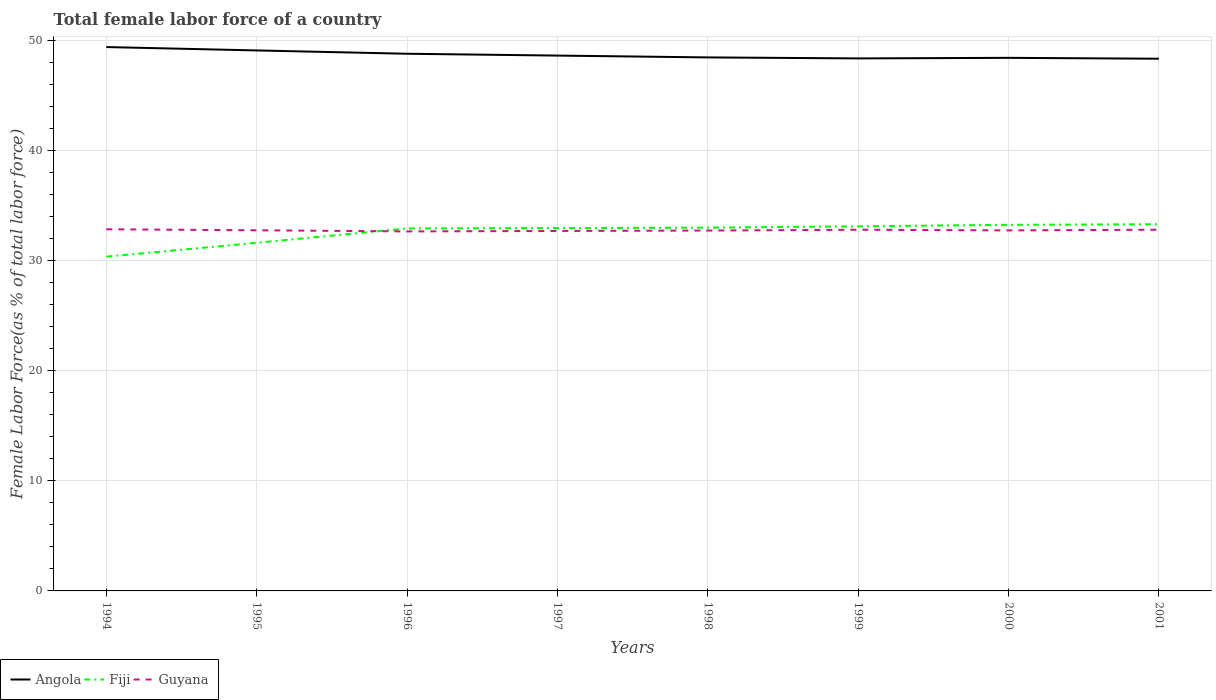How many different coloured lines are there?
Keep it short and to the point. 3. Is the number of lines equal to the number of legend labels?
Offer a terse response. Yes. Across all years, what is the maximum percentage of female labor force in Angola?
Your answer should be very brief. 48.34. What is the total percentage of female labor force in Fiji in the graph?
Give a very brief answer. -0.12. What is the difference between the highest and the second highest percentage of female labor force in Angola?
Ensure brevity in your answer.  1.06. What is the difference between the highest and the lowest percentage of female labor force in Angola?
Your answer should be compact. 3. How many lines are there?
Offer a very short reply. 3. Are the values on the major ticks of Y-axis written in scientific E-notation?
Ensure brevity in your answer.  No. Does the graph contain grids?
Your answer should be compact. Yes. Where does the legend appear in the graph?
Provide a succinct answer. Bottom left. How many legend labels are there?
Your answer should be compact. 3. What is the title of the graph?
Provide a short and direct response. Total female labor force of a country. Does "Guam" appear as one of the legend labels in the graph?
Your answer should be compact. No. What is the label or title of the X-axis?
Provide a succinct answer. Years. What is the label or title of the Y-axis?
Your answer should be very brief. Female Labor Force(as % of total labor force). What is the Female Labor Force(as % of total labor force) in Angola in 1994?
Your answer should be compact. 49.4. What is the Female Labor Force(as % of total labor force) of Fiji in 1994?
Give a very brief answer. 30.36. What is the Female Labor Force(as % of total labor force) in Guyana in 1994?
Offer a very short reply. 32.85. What is the Female Labor Force(as % of total labor force) of Angola in 1995?
Your answer should be compact. 49.09. What is the Female Labor Force(as % of total labor force) in Fiji in 1995?
Keep it short and to the point. 31.62. What is the Female Labor Force(as % of total labor force) in Guyana in 1995?
Your answer should be very brief. 32.76. What is the Female Labor Force(as % of total labor force) of Angola in 1996?
Offer a very short reply. 48.79. What is the Female Labor Force(as % of total labor force) in Fiji in 1996?
Give a very brief answer. 32.92. What is the Female Labor Force(as % of total labor force) in Guyana in 1996?
Your answer should be very brief. 32.66. What is the Female Labor Force(as % of total labor force) in Angola in 1997?
Your response must be concise. 48.63. What is the Female Labor Force(as % of total labor force) in Fiji in 1997?
Give a very brief answer. 32.96. What is the Female Labor Force(as % of total labor force) in Guyana in 1997?
Your response must be concise. 32.69. What is the Female Labor Force(as % of total labor force) in Angola in 1998?
Offer a very short reply. 48.46. What is the Female Labor Force(as % of total labor force) of Fiji in 1998?
Your answer should be very brief. 33. What is the Female Labor Force(as % of total labor force) of Guyana in 1998?
Offer a terse response. 32.73. What is the Female Labor Force(as % of total labor force) in Angola in 1999?
Keep it short and to the point. 48.37. What is the Female Labor Force(as % of total labor force) of Fiji in 1999?
Keep it short and to the point. 33.12. What is the Female Labor Force(as % of total labor force) in Guyana in 1999?
Provide a short and direct response. 32.81. What is the Female Labor Force(as % of total labor force) of Angola in 2000?
Keep it short and to the point. 48.42. What is the Female Labor Force(as % of total labor force) of Fiji in 2000?
Provide a short and direct response. 33.25. What is the Female Labor Force(as % of total labor force) of Guyana in 2000?
Provide a succinct answer. 32.75. What is the Female Labor Force(as % of total labor force) in Angola in 2001?
Provide a succinct answer. 48.34. What is the Female Labor Force(as % of total labor force) in Fiji in 2001?
Your response must be concise. 33.31. What is the Female Labor Force(as % of total labor force) of Guyana in 2001?
Keep it short and to the point. 32.81. Across all years, what is the maximum Female Labor Force(as % of total labor force) of Angola?
Keep it short and to the point. 49.4. Across all years, what is the maximum Female Labor Force(as % of total labor force) in Fiji?
Ensure brevity in your answer.  33.31. Across all years, what is the maximum Female Labor Force(as % of total labor force) in Guyana?
Your response must be concise. 32.85. Across all years, what is the minimum Female Labor Force(as % of total labor force) in Angola?
Your answer should be very brief. 48.34. Across all years, what is the minimum Female Labor Force(as % of total labor force) in Fiji?
Make the answer very short. 30.36. Across all years, what is the minimum Female Labor Force(as % of total labor force) in Guyana?
Provide a short and direct response. 32.66. What is the total Female Labor Force(as % of total labor force) of Angola in the graph?
Give a very brief answer. 389.51. What is the total Female Labor Force(as % of total labor force) of Fiji in the graph?
Your answer should be very brief. 260.55. What is the total Female Labor Force(as % of total labor force) in Guyana in the graph?
Keep it short and to the point. 262.06. What is the difference between the Female Labor Force(as % of total labor force) in Angola in 1994 and that in 1995?
Ensure brevity in your answer.  0.31. What is the difference between the Female Labor Force(as % of total labor force) of Fiji in 1994 and that in 1995?
Offer a very short reply. -1.26. What is the difference between the Female Labor Force(as % of total labor force) in Guyana in 1994 and that in 1995?
Keep it short and to the point. 0.09. What is the difference between the Female Labor Force(as % of total labor force) of Angola in 1994 and that in 1996?
Offer a very short reply. 0.61. What is the difference between the Female Labor Force(as % of total labor force) of Fiji in 1994 and that in 1996?
Offer a terse response. -2.56. What is the difference between the Female Labor Force(as % of total labor force) in Guyana in 1994 and that in 1996?
Offer a terse response. 0.19. What is the difference between the Female Labor Force(as % of total labor force) of Angola in 1994 and that in 1997?
Give a very brief answer. 0.77. What is the difference between the Female Labor Force(as % of total labor force) of Fiji in 1994 and that in 1997?
Keep it short and to the point. -2.6. What is the difference between the Female Labor Force(as % of total labor force) in Guyana in 1994 and that in 1997?
Give a very brief answer. 0.15. What is the difference between the Female Labor Force(as % of total labor force) of Angola in 1994 and that in 1998?
Provide a succinct answer. 0.94. What is the difference between the Female Labor Force(as % of total labor force) in Fiji in 1994 and that in 1998?
Ensure brevity in your answer.  -2.64. What is the difference between the Female Labor Force(as % of total labor force) in Guyana in 1994 and that in 1998?
Make the answer very short. 0.12. What is the difference between the Female Labor Force(as % of total labor force) in Angola in 1994 and that in 1999?
Give a very brief answer. 1.03. What is the difference between the Female Labor Force(as % of total labor force) in Fiji in 1994 and that in 1999?
Provide a succinct answer. -2.75. What is the difference between the Female Labor Force(as % of total labor force) in Guyana in 1994 and that in 1999?
Provide a succinct answer. 0.04. What is the difference between the Female Labor Force(as % of total labor force) of Angola in 1994 and that in 2000?
Offer a terse response. 0.98. What is the difference between the Female Labor Force(as % of total labor force) of Fiji in 1994 and that in 2000?
Your response must be concise. -2.89. What is the difference between the Female Labor Force(as % of total labor force) of Guyana in 1994 and that in 2000?
Offer a terse response. 0.1. What is the difference between the Female Labor Force(as % of total labor force) of Angola in 1994 and that in 2001?
Offer a terse response. 1.06. What is the difference between the Female Labor Force(as % of total labor force) in Fiji in 1994 and that in 2001?
Your response must be concise. -2.94. What is the difference between the Female Labor Force(as % of total labor force) in Guyana in 1994 and that in 2001?
Offer a terse response. 0.04. What is the difference between the Female Labor Force(as % of total labor force) of Angola in 1995 and that in 1996?
Keep it short and to the point. 0.3. What is the difference between the Female Labor Force(as % of total labor force) of Fiji in 1995 and that in 1996?
Provide a short and direct response. -1.3. What is the difference between the Female Labor Force(as % of total labor force) in Guyana in 1995 and that in 1996?
Provide a succinct answer. 0.1. What is the difference between the Female Labor Force(as % of total labor force) in Angola in 1995 and that in 1997?
Offer a terse response. 0.47. What is the difference between the Female Labor Force(as % of total labor force) in Fiji in 1995 and that in 1997?
Provide a short and direct response. -1.34. What is the difference between the Female Labor Force(as % of total labor force) of Guyana in 1995 and that in 1997?
Keep it short and to the point. 0.06. What is the difference between the Female Labor Force(as % of total labor force) in Angola in 1995 and that in 1998?
Provide a short and direct response. 0.63. What is the difference between the Female Labor Force(as % of total labor force) in Fiji in 1995 and that in 1998?
Keep it short and to the point. -1.38. What is the difference between the Female Labor Force(as % of total labor force) in Guyana in 1995 and that in 1998?
Ensure brevity in your answer.  0.03. What is the difference between the Female Labor Force(as % of total labor force) of Angola in 1995 and that in 1999?
Give a very brief answer. 0.72. What is the difference between the Female Labor Force(as % of total labor force) of Fiji in 1995 and that in 1999?
Make the answer very short. -1.49. What is the difference between the Female Labor Force(as % of total labor force) in Guyana in 1995 and that in 1999?
Your response must be concise. -0.05. What is the difference between the Female Labor Force(as % of total labor force) in Angola in 1995 and that in 2000?
Make the answer very short. 0.67. What is the difference between the Female Labor Force(as % of total labor force) in Fiji in 1995 and that in 2000?
Make the answer very short. -1.63. What is the difference between the Female Labor Force(as % of total labor force) of Guyana in 1995 and that in 2000?
Your answer should be very brief. 0.01. What is the difference between the Female Labor Force(as % of total labor force) in Angola in 1995 and that in 2001?
Offer a terse response. 0.75. What is the difference between the Female Labor Force(as % of total labor force) in Fiji in 1995 and that in 2001?
Keep it short and to the point. -1.68. What is the difference between the Female Labor Force(as % of total labor force) of Guyana in 1995 and that in 2001?
Your response must be concise. -0.05. What is the difference between the Female Labor Force(as % of total labor force) in Angola in 1996 and that in 1997?
Provide a short and direct response. 0.17. What is the difference between the Female Labor Force(as % of total labor force) in Fiji in 1996 and that in 1997?
Your response must be concise. -0.04. What is the difference between the Female Labor Force(as % of total labor force) in Guyana in 1996 and that in 1997?
Your answer should be compact. -0.04. What is the difference between the Female Labor Force(as % of total labor force) in Angola in 1996 and that in 1998?
Offer a terse response. 0.33. What is the difference between the Female Labor Force(as % of total labor force) of Fiji in 1996 and that in 1998?
Your response must be concise. -0.08. What is the difference between the Female Labor Force(as % of total labor force) of Guyana in 1996 and that in 1998?
Your answer should be very brief. -0.08. What is the difference between the Female Labor Force(as % of total labor force) in Angola in 1996 and that in 1999?
Offer a terse response. 0.42. What is the difference between the Female Labor Force(as % of total labor force) in Fiji in 1996 and that in 1999?
Your answer should be very brief. -0.19. What is the difference between the Female Labor Force(as % of total labor force) of Guyana in 1996 and that in 1999?
Provide a short and direct response. -0.15. What is the difference between the Female Labor Force(as % of total labor force) in Angola in 1996 and that in 2000?
Offer a terse response. 0.37. What is the difference between the Female Labor Force(as % of total labor force) of Fiji in 1996 and that in 2000?
Your response must be concise. -0.33. What is the difference between the Female Labor Force(as % of total labor force) of Guyana in 1996 and that in 2000?
Keep it short and to the point. -0.09. What is the difference between the Female Labor Force(as % of total labor force) in Angola in 1996 and that in 2001?
Give a very brief answer. 0.45. What is the difference between the Female Labor Force(as % of total labor force) in Fiji in 1996 and that in 2001?
Offer a terse response. -0.38. What is the difference between the Female Labor Force(as % of total labor force) of Guyana in 1996 and that in 2001?
Give a very brief answer. -0.15. What is the difference between the Female Labor Force(as % of total labor force) in Angola in 1997 and that in 1998?
Your answer should be very brief. 0.17. What is the difference between the Female Labor Force(as % of total labor force) in Fiji in 1997 and that in 1998?
Ensure brevity in your answer.  -0.04. What is the difference between the Female Labor Force(as % of total labor force) in Guyana in 1997 and that in 1998?
Your response must be concise. -0.04. What is the difference between the Female Labor Force(as % of total labor force) in Angola in 1997 and that in 1999?
Ensure brevity in your answer.  0.26. What is the difference between the Female Labor Force(as % of total labor force) of Fiji in 1997 and that in 1999?
Give a very brief answer. -0.15. What is the difference between the Female Labor Force(as % of total labor force) of Guyana in 1997 and that in 1999?
Offer a very short reply. -0.11. What is the difference between the Female Labor Force(as % of total labor force) in Angola in 1997 and that in 2000?
Keep it short and to the point. 0.21. What is the difference between the Female Labor Force(as % of total labor force) of Fiji in 1997 and that in 2000?
Make the answer very short. -0.29. What is the difference between the Female Labor Force(as % of total labor force) of Guyana in 1997 and that in 2000?
Make the answer very short. -0.05. What is the difference between the Female Labor Force(as % of total labor force) of Angola in 1997 and that in 2001?
Your response must be concise. 0.29. What is the difference between the Female Labor Force(as % of total labor force) of Fiji in 1997 and that in 2001?
Your answer should be very brief. -0.34. What is the difference between the Female Labor Force(as % of total labor force) of Guyana in 1997 and that in 2001?
Keep it short and to the point. -0.11. What is the difference between the Female Labor Force(as % of total labor force) of Angola in 1998 and that in 1999?
Keep it short and to the point. 0.09. What is the difference between the Female Labor Force(as % of total labor force) of Fiji in 1998 and that in 1999?
Your answer should be compact. -0.12. What is the difference between the Female Labor Force(as % of total labor force) of Guyana in 1998 and that in 1999?
Provide a succinct answer. -0.07. What is the difference between the Female Labor Force(as % of total labor force) of Angola in 1998 and that in 2000?
Ensure brevity in your answer.  0.04. What is the difference between the Female Labor Force(as % of total labor force) of Fiji in 1998 and that in 2000?
Ensure brevity in your answer.  -0.25. What is the difference between the Female Labor Force(as % of total labor force) in Guyana in 1998 and that in 2000?
Make the answer very short. -0.01. What is the difference between the Female Labor Force(as % of total labor force) of Angola in 1998 and that in 2001?
Offer a terse response. 0.12. What is the difference between the Female Labor Force(as % of total labor force) in Fiji in 1998 and that in 2001?
Ensure brevity in your answer.  -0.31. What is the difference between the Female Labor Force(as % of total labor force) in Guyana in 1998 and that in 2001?
Offer a terse response. -0.08. What is the difference between the Female Labor Force(as % of total labor force) in Angola in 1999 and that in 2000?
Provide a succinct answer. -0.05. What is the difference between the Female Labor Force(as % of total labor force) of Fiji in 1999 and that in 2000?
Give a very brief answer. -0.14. What is the difference between the Female Labor Force(as % of total labor force) of Guyana in 1999 and that in 2000?
Ensure brevity in your answer.  0.06. What is the difference between the Female Labor Force(as % of total labor force) of Angola in 1999 and that in 2001?
Your answer should be very brief. 0.03. What is the difference between the Female Labor Force(as % of total labor force) of Fiji in 1999 and that in 2001?
Your answer should be very brief. -0.19. What is the difference between the Female Labor Force(as % of total labor force) of Guyana in 1999 and that in 2001?
Your response must be concise. -0. What is the difference between the Female Labor Force(as % of total labor force) in Angola in 2000 and that in 2001?
Keep it short and to the point. 0.08. What is the difference between the Female Labor Force(as % of total labor force) of Fiji in 2000 and that in 2001?
Provide a short and direct response. -0.05. What is the difference between the Female Labor Force(as % of total labor force) in Guyana in 2000 and that in 2001?
Offer a terse response. -0.06. What is the difference between the Female Labor Force(as % of total labor force) of Angola in 1994 and the Female Labor Force(as % of total labor force) of Fiji in 1995?
Provide a short and direct response. 17.78. What is the difference between the Female Labor Force(as % of total labor force) in Angola in 1994 and the Female Labor Force(as % of total labor force) in Guyana in 1995?
Your answer should be very brief. 16.64. What is the difference between the Female Labor Force(as % of total labor force) of Fiji in 1994 and the Female Labor Force(as % of total labor force) of Guyana in 1995?
Offer a very short reply. -2.4. What is the difference between the Female Labor Force(as % of total labor force) of Angola in 1994 and the Female Labor Force(as % of total labor force) of Fiji in 1996?
Keep it short and to the point. 16.48. What is the difference between the Female Labor Force(as % of total labor force) of Angola in 1994 and the Female Labor Force(as % of total labor force) of Guyana in 1996?
Keep it short and to the point. 16.75. What is the difference between the Female Labor Force(as % of total labor force) of Fiji in 1994 and the Female Labor Force(as % of total labor force) of Guyana in 1996?
Keep it short and to the point. -2.29. What is the difference between the Female Labor Force(as % of total labor force) in Angola in 1994 and the Female Labor Force(as % of total labor force) in Fiji in 1997?
Give a very brief answer. 16.44. What is the difference between the Female Labor Force(as % of total labor force) of Angola in 1994 and the Female Labor Force(as % of total labor force) of Guyana in 1997?
Your answer should be very brief. 16.71. What is the difference between the Female Labor Force(as % of total labor force) in Fiji in 1994 and the Female Labor Force(as % of total labor force) in Guyana in 1997?
Provide a succinct answer. -2.33. What is the difference between the Female Labor Force(as % of total labor force) in Angola in 1994 and the Female Labor Force(as % of total labor force) in Fiji in 1998?
Offer a terse response. 16.4. What is the difference between the Female Labor Force(as % of total labor force) in Angola in 1994 and the Female Labor Force(as % of total labor force) in Guyana in 1998?
Offer a very short reply. 16.67. What is the difference between the Female Labor Force(as % of total labor force) of Fiji in 1994 and the Female Labor Force(as % of total labor force) of Guyana in 1998?
Offer a very short reply. -2.37. What is the difference between the Female Labor Force(as % of total labor force) in Angola in 1994 and the Female Labor Force(as % of total labor force) in Fiji in 1999?
Your response must be concise. 16.28. What is the difference between the Female Labor Force(as % of total labor force) of Angola in 1994 and the Female Labor Force(as % of total labor force) of Guyana in 1999?
Make the answer very short. 16.59. What is the difference between the Female Labor Force(as % of total labor force) of Fiji in 1994 and the Female Labor Force(as % of total labor force) of Guyana in 1999?
Your response must be concise. -2.44. What is the difference between the Female Labor Force(as % of total labor force) of Angola in 1994 and the Female Labor Force(as % of total labor force) of Fiji in 2000?
Your answer should be compact. 16.15. What is the difference between the Female Labor Force(as % of total labor force) of Angola in 1994 and the Female Labor Force(as % of total labor force) of Guyana in 2000?
Keep it short and to the point. 16.65. What is the difference between the Female Labor Force(as % of total labor force) in Fiji in 1994 and the Female Labor Force(as % of total labor force) in Guyana in 2000?
Give a very brief answer. -2.39. What is the difference between the Female Labor Force(as % of total labor force) of Angola in 1994 and the Female Labor Force(as % of total labor force) of Fiji in 2001?
Ensure brevity in your answer.  16.09. What is the difference between the Female Labor Force(as % of total labor force) in Angola in 1994 and the Female Labor Force(as % of total labor force) in Guyana in 2001?
Your answer should be very brief. 16.59. What is the difference between the Female Labor Force(as % of total labor force) in Fiji in 1994 and the Female Labor Force(as % of total labor force) in Guyana in 2001?
Your answer should be compact. -2.45. What is the difference between the Female Labor Force(as % of total labor force) in Angola in 1995 and the Female Labor Force(as % of total labor force) in Fiji in 1996?
Give a very brief answer. 16.17. What is the difference between the Female Labor Force(as % of total labor force) in Angola in 1995 and the Female Labor Force(as % of total labor force) in Guyana in 1996?
Your answer should be compact. 16.44. What is the difference between the Female Labor Force(as % of total labor force) in Fiji in 1995 and the Female Labor Force(as % of total labor force) in Guyana in 1996?
Give a very brief answer. -1.03. What is the difference between the Female Labor Force(as % of total labor force) in Angola in 1995 and the Female Labor Force(as % of total labor force) in Fiji in 1997?
Ensure brevity in your answer.  16.13. What is the difference between the Female Labor Force(as % of total labor force) in Angola in 1995 and the Female Labor Force(as % of total labor force) in Guyana in 1997?
Your response must be concise. 16.4. What is the difference between the Female Labor Force(as % of total labor force) in Fiji in 1995 and the Female Labor Force(as % of total labor force) in Guyana in 1997?
Your answer should be very brief. -1.07. What is the difference between the Female Labor Force(as % of total labor force) of Angola in 1995 and the Female Labor Force(as % of total labor force) of Fiji in 1998?
Provide a short and direct response. 16.09. What is the difference between the Female Labor Force(as % of total labor force) of Angola in 1995 and the Female Labor Force(as % of total labor force) of Guyana in 1998?
Make the answer very short. 16.36. What is the difference between the Female Labor Force(as % of total labor force) of Fiji in 1995 and the Female Labor Force(as % of total labor force) of Guyana in 1998?
Your answer should be very brief. -1.11. What is the difference between the Female Labor Force(as % of total labor force) in Angola in 1995 and the Female Labor Force(as % of total labor force) in Fiji in 1999?
Your answer should be very brief. 15.98. What is the difference between the Female Labor Force(as % of total labor force) in Angola in 1995 and the Female Labor Force(as % of total labor force) in Guyana in 1999?
Keep it short and to the point. 16.29. What is the difference between the Female Labor Force(as % of total labor force) of Fiji in 1995 and the Female Labor Force(as % of total labor force) of Guyana in 1999?
Your answer should be compact. -1.18. What is the difference between the Female Labor Force(as % of total labor force) in Angola in 1995 and the Female Labor Force(as % of total labor force) in Fiji in 2000?
Keep it short and to the point. 15.84. What is the difference between the Female Labor Force(as % of total labor force) in Angola in 1995 and the Female Labor Force(as % of total labor force) in Guyana in 2000?
Provide a succinct answer. 16.35. What is the difference between the Female Labor Force(as % of total labor force) of Fiji in 1995 and the Female Labor Force(as % of total labor force) of Guyana in 2000?
Ensure brevity in your answer.  -1.13. What is the difference between the Female Labor Force(as % of total labor force) of Angola in 1995 and the Female Labor Force(as % of total labor force) of Fiji in 2001?
Your answer should be compact. 15.79. What is the difference between the Female Labor Force(as % of total labor force) of Angola in 1995 and the Female Labor Force(as % of total labor force) of Guyana in 2001?
Your answer should be very brief. 16.28. What is the difference between the Female Labor Force(as % of total labor force) in Fiji in 1995 and the Female Labor Force(as % of total labor force) in Guyana in 2001?
Give a very brief answer. -1.19. What is the difference between the Female Labor Force(as % of total labor force) of Angola in 1996 and the Female Labor Force(as % of total labor force) of Fiji in 1997?
Provide a succinct answer. 15.83. What is the difference between the Female Labor Force(as % of total labor force) in Angola in 1996 and the Female Labor Force(as % of total labor force) in Guyana in 1997?
Make the answer very short. 16.1. What is the difference between the Female Labor Force(as % of total labor force) in Fiji in 1996 and the Female Labor Force(as % of total labor force) in Guyana in 1997?
Offer a terse response. 0.23. What is the difference between the Female Labor Force(as % of total labor force) of Angola in 1996 and the Female Labor Force(as % of total labor force) of Fiji in 1998?
Offer a terse response. 15.79. What is the difference between the Female Labor Force(as % of total labor force) of Angola in 1996 and the Female Labor Force(as % of total labor force) of Guyana in 1998?
Offer a very short reply. 16.06. What is the difference between the Female Labor Force(as % of total labor force) in Fiji in 1996 and the Female Labor Force(as % of total labor force) in Guyana in 1998?
Provide a short and direct response. 0.19. What is the difference between the Female Labor Force(as % of total labor force) of Angola in 1996 and the Female Labor Force(as % of total labor force) of Fiji in 1999?
Give a very brief answer. 15.68. What is the difference between the Female Labor Force(as % of total labor force) in Angola in 1996 and the Female Labor Force(as % of total labor force) in Guyana in 1999?
Provide a succinct answer. 15.99. What is the difference between the Female Labor Force(as % of total labor force) in Fiji in 1996 and the Female Labor Force(as % of total labor force) in Guyana in 1999?
Give a very brief answer. 0.12. What is the difference between the Female Labor Force(as % of total labor force) of Angola in 1996 and the Female Labor Force(as % of total labor force) of Fiji in 2000?
Provide a succinct answer. 15.54. What is the difference between the Female Labor Force(as % of total labor force) in Angola in 1996 and the Female Labor Force(as % of total labor force) in Guyana in 2000?
Provide a short and direct response. 16.04. What is the difference between the Female Labor Force(as % of total labor force) in Fiji in 1996 and the Female Labor Force(as % of total labor force) in Guyana in 2000?
Give a very brief answer. 0.18. What is the difference between the Female Labor Force(as % of total labor force) in Angola in 1996 and the Female Labor Force(as % of total labor force) in Fiji in 2001?
Offer a terse response. 15.49. What is the difference between the Female Labor Force(as % of total labor force) of Angola in 1996 and the Female Labor Force(as % of total labor force) of Guyana in 2001?
Your answer should be compact. 15.98. What is the difference between the Female Labor Force(as % of total labor force) of Fiji in 1996 and the Female Labor Force(as % of total labor force) of Guyana in 2001?
Your response must be concise. 0.11. What is the difference between the Female Labor Force(as % of total labor force) in Angola in 1997 and the Female Labor Force(as % of total labor force) in Fiji in 1998?
Offer a terse response. 15.63. What is the difference between the Female Labor Force(as % of total labor force) in Angola in 1997 and the Female Labor Force(as % of total labor force) in Guyana in 1998?
Give a very brief answer. 15.89. What is the difference between the Female Labor Force(as % of total labor force) of Fiji in 1997 and the Female Labor Force(as % of total labor force) of Guyana in 1998?
Your answer should be compact. 0.23. What is the difference between the Female Labor Force(as % of total labor force) of Angola in 1997 and the Female Labor Force(as % of total labor force) of Fiji in 1999?
Make the answer very short. 15.51. What is the difference between the Female Labor Force(as % of total labor force) in Angola in 1997 and the Female Labor Force(as % of total labor force) in Guyana in 1999?
Ensure brevity in your answer.  15.82. What is the difference between the Female Labor Force(as % of total labor force) of Fiji in 1997 and the Female Labor Force(as % of total labor force) of Guyana in 1999?
Ensure brevity in your answer.  0.16. What is the difference between the Female Labor Force(as % of total labor force) in Angola in 1997 and the Female Labor Force(as % of total labor force) in Fiji in 2000?
Provide a succinct answer. 15.37. What is the difference between the Female Labor Force(as % of total labor force) in Angola in 1997 and the Female Labor Force(as % of total labor force) in Guyana in 2000?
Offer a terse response. 15.88. What is the difference between the Female Labor Force(as % of total labor force) in Fiji in 1997 and the Female Labor Force(as % of total labor force) in Guyana in 2000?
Offer a terse response. 0.21. What is the difference between the Female Labor Force(as % of total labor force) of Angola in 1997 and the Female Labor Force(as % of total labor force) of Fiji in 2001?
Ensure brevity in your answer.  15.32. What is the difference between the Female Labor Force(as % of total labor force) in Angola in 1997 and the Female Labor Force(as % of total labor force) in Guyana in 2001?
Make the answer very short. 15.82. What is the difference between the Female Labor Force(as % of total labor force) in Fiji in 1997 and the Female Labor Force(as % of total labor force) in Guyana in 2001?
Provide a succinct answer. 0.15. What is the difference between the Female Labor Force(as % of total labor force) in Angola in 1998 and the Female Labor Force(as % of total labor force) in Fiji in 1999?
Give a very brief answer. 15.34. What is the difference between the Female Labor Force(as % of total labor force) of Angola in 1998 and the Female Labor Force(as % of total labor force) of Guyana in 1999?
Offer a terse response. 15.65. What is the difference between the Female Labor Force(as % of total labor force) in Fiji in 1998 and the Female Labor Force(as % of total labor force) in Guyana in 1999?
Provide a succinct answer. 0.19. What is the difference between the Female Labor Force(as % of total labor force) of Angola in 1998 and the Female Labor Force(as % of total labor force) of Fiji in 2000?
Your answer should be very brief. 15.21. What is the difference between the Female Labor Force(as % of total labor force) in Angola in 1998 and the Female Labor Force(as % of total labor force) in Guyana in 2000?
Your response must be concise. 15.71. What is the difference between the Female Labor Force(as % of total labor force) of Fiji in 1998 and the Female Labor Force(as % of total labor force) of Guyana in 2000?
Your answer should be very brief. 0.25. What is the difference between the Female Labor Force(as % of total labor force) of Angola in 1998 and the Female Labor Force(as % of total labor force) of Fiji in 2001?
Give a very brief answer. 15.15. What is the difference between the Female Labor Force(as % of total labor force) in Angola in 1998 and the Female Labor Force(as % of total labor force) in Guyana in 2001?
Make the answer very short. 15.65. What is the difference between the Female Labor Force(as % of total labor force) in Fiji in 1998 and the Female Labor Force(as % of total labor force) in Guyana in 2001?
Offer a very short reply. 0.19. What is the difference between the Female Labor Force(as % of total labor force) in Angola in 1999 and the Female Labor Force(as % of total labor force) in Fiji in 2000?
Your answer should be compact. 15.12. What is the difference between the Female Labor Force(as % of total labor force) in Angola in 1999 and the Female Labor Force(as % of total labor force) in Guyana in 2000?
Your response must be concise. 15.62. What is the difference between the Female Labor Force(as % of total labor force) in Fiji in 1999 and the Female Labor Force(as % of total labor force) in Guyana in 2000?
Make the answer very short. 0.37. What is the difference between the Female Labor Force(as % of total labor force) of Angola in 1999 and the Female Labor Force(as % of total labor force) of Fiji in 2001?
Make the answer very short. 15.06. What is the difference between the Female Labor Force(as % of total labor force) of Angola in 1999 and the Female Labor Force(as % of total labor force) of Guyana in 2001?
Provide a succinct answer. 15.56. What is the difference between the Female Labor Force(as % of total labor force) of Fiji in 1999 and the Female Labor Force(as % of total labor force) of Guyana in 2001?
Keep it short and to the point. 0.31. What is the difference between the Female Labor Force(as % of total labor force) in Angola in 2000 and the Female Labor Force(as % of total labor force) in Fiji in 2001?
Your response must be concise. 15.11. What is the difference between the Female Labor Force(as % of total labor force) of Angola in 2000 and the Female Labor Force(as % of total labor force) of Guyana in 2001?
Ensure brevity in your answer.  15.61. What is the difference between the Female Labor Force(as % of total labor force) of Fiji in 2000 and the Female Labor Force(as % of total labor force) of Guyana in 2001?
Offer a terse response. 0.44. What is the average Female Labor Force(as % of total labor force) in Angola per year?
Offer a terse response. 48.69. What is the average Female Labor Force(as % of total labor force) in Fiji per year?
Make the answer very short. 32.57. What is the average Female Labor Force(as % of total labor force) in Guyana per year?
Provide a short and direct response. 32.76. In the year 1994, what is the difference between the Female Labor Force(as % of total labor force) of Angola and Female Labor Force(as % of total labor force) of Fiji?
Provide a short and direct response. 19.04. In the year 1994, what is the difference between the Female Labor Force(as % of total labor force) in Angola and Female Labor Force(as % of total labor force) in Guyana?
Offer a terse response. 16.55. In the year 1994, what is the difference between the Female Labor Force(as % of total labor force) of Fiji and Female Labor Force(as % of total labor force) of Guyana?
Offer a very short reply. -2.49. In the year 1995, what is the difference between the Female Labor Force(as % of total labor force) in Angola and Female Labor Force(as % of total labor force) in Fiji?
Make the answer very short. 17.47. In the year 1995, what is the difference between the Female Labor Force(as % of total labor force) of Angola and Female Labor Force(as % of total labor force) of Guyana?
Offer a very short reply. 16.34. In the year 1995, what is the difference between the Female Labor Force(as % of total labor force) in Fiji and Female Labor Force(as % of total labor force) in Guyana?
Keep it short and to the point. -1.14. In the year 1996, what is the difference between the Female Labor Force(as % of total labor force) of Angola and Female Labor Force(as % of total labor force) of Fiji?
Give a very brief answer. 15.87. In the year 1996, what is the difference between the Female Labor Force(as % of total labor force) of Angola and Female Labor Force(as % of total labor force) of Guyana?
Keep it short and to the point. 16.14. In the year 1996, what is the difference between the Female Labor Force(as % of total labor force) in Fiji and Female Labor Force(as % of total labor force) in Guyana?
Your answer should be very brief. 0.27. In the year 1997, what is the difference between the Female Labor Force(as % of total labor force) in Angola and Female Labor Force(as % of total labor force) in Fiji?
Provide a succinct answer. 15.66. In the year 1997, what is the difference between the Female Labor Force(as % of total labor force) in Angola and Female Labor Force(as % of total labor force) in Guyana?
Your response must be concise. 15.93. In the year 1997, what is the difference between the Female Labor Force(as % of total labor force) in Fiji and Female Labor Force(as % of total labor force) in Guyana?
Keep it short and to the point. 0.27. In the year 1998, what is the difference between the Female Labor Force(as % of total labor force) in Angola and Female Labor Force(as % of total labor force) in Fiji?
Your response must be concise. 15.46. In the year 1998, what is the difference between the Female Labor Force(as % of total labor force) in Angola and Female Labor Force(as % of total labor force) in Guyana?
Your answer should be very brief. 15.73. In the year 1998, what is the difference between the Female Labor Force(as % of total labor force) in Fiji and Female Labor Force(as % of total labor force) in Guyana?
Your answer should be compact. 0.27. In the year 1999, what is the difference between the Female Labor Force(as % of total labor force) in Angola and Female Labor Force(as % of total labor force) in Fiji?
Give a very brief answer. 15.25. In the year 1999, what is the difference between the Female Labor Force(as % of total labor force) in Angola and Female Labor Force(as % of total labor force) in Guyana?
Your answer should be very brief. 15.56. In the year 1999, what is the difference between the Female Labor Force(as % of total labor force) of Fiji and Female Labor Force(as % of total labor force) of Guyana?
Provide a succinct answer. 0.31. In the year 2000, what is the difference between the Female Labor Force(as % of total labor force) of Angola and Female Labor Force(as % of total labor force) of Fiji?
Keep it short and to the point. 15.17. In the year 2000, what is the difference between the Female Labor Force(as % of total labor force) of Angola and Female Labor Force(as % of total labor force) of Guyana?
Your response must be concise. 15.67. In the year 2000, what is the difference between the Female Labor Force(as % of total labor force) of Fiji and Female Labor Force(as % of total labor force) of Guyana?
Keep it short and to the point. 0.51. In the year 2001, what is the difference between the Female Labor Force(as % of total labor force) in Angola and Female Labor Force(as % of total labor force) in Fiji?
Provide a short and direct response. 15.03. In the year 2001, what is the difference between the Female Labor Force(as % of total labor force) of Angola and Female Labor Force(as % of total labor force) of Guyana?
Ensure brevity in your answer.  15.53. In the year 2001, what is the difference between the Female Labor Force(as % of total labor force) in Fiji and Female Labor Force(as % of total labor force) in Guyana?
Offer a terse response. 0.5. What is the ratio of the Female Labor Force(as % of total labor force) of Angola in 1994 to that in 1995?
Provide a short and direct response. 1.01. What is the ratio of the Female Labor Force(as % of total labor force) in Fiji in 1994 to that in 1995?
Your answer should be compact. 0.96. What is the ratio of the Female Labor Force(as % of total labor force) in Angola in 1994 to that in 1996?
Provide a short and direct response. 1.01. What is the ratio of the Female Labor Force(as % of total labor force) in Fiji in 1994 to that in 1996?
Give a very brief answer. 0.92. What is the ratio of the Female Labor Force(as % of total labor force) of Guyana in 1994 to that in 1996?
Give a very brief answer. 1.01. What is the ratio of the Female Labor Force(as % of total labor force) in Angola in 1994 to that in 1997?
Your answer should be compact. 1.02. What is the ratio of the Female Labor Force(as % of total labor force) in Fiji in 1994 to that in 1997?
Ensure brevity in your answer.  0.92. What is the ratio of the Female Labor Force(as % of total labor force) in Guyana in 1994 to that in 1997?
Give a very brief answer. 1. What is the ratio of the Female Labor Force(as % of total labor force) of Angola in 1994 to that in 1998?
Your response must be concise. 1.02. What is the ratio of the Female Labor Force(as % of total labor force) in Fiji in 1994 to that in 1998?
Your response must be concise. 0.92. What is the ratio of the Female Labor Force(as % of total labor force) of Angola in 1994 to that in 1999?
Your answer should be compact. 1.02. What is the ratio of the Female Labor Force(as % of total labor force) of Fiji in 1994 to that in 1999?
Your answer should be compact. 0.92. What is the ratio of the Female Labor Force(as % of total labor force) of Angola in 1994 to that in 2000?
Ensure brevity in your answer.  1.02. What is the ratio of the Female Labor Force(as % of total labor force) in Fiji in 1994 to that in 2000?
Provide a succinct answer. 0.91. What is the ratio of the Female Labor Force(as % of total labor force) in Angola in 1994 to that in 2001?
Make the answer very short. 1.02. What is the ratio of the Female Labor Force(as % of total labor force) of Fiji in 1994 to that in 2001?
Your response must be concise. 0.91. What is the ratio of the Female Labor Force(as % of total labor force) in Guyana in 1994 to that in 2001?
Ensure brevity in your answer.  1. What is the ratio of the Female Labor Force(as % of total labor force) of Angola in 1995 to that in 1996?
Offer a terse response. 1.01. What is the ratio of the Female Labor Force(as % of total labor force) of Fiji in 1995 to that in 1996?
Keep it short and to the point. 0.96. What is the ratio of the Female Labor Force(as % of total labor force) in Angola in 1995 to that in 1997?
Keep it short and to the point. 1.01. What is the ratio of the Female Labor Force(as % of total labor force) of Fiji in 1995 to that in 1997?
Offer a very short reply. 0.96. What is the ratio of the Female Labor Force(as % of total labor force) of Angola in 1995 to that in 1998?
Your answer should be very brief. 1.01. What is the ratio of the Female Labor Force(as % of total labor force) of Fiji in 1995 to that in 1998?
Your answer should be very brief. 0.96. What is the ratio of the Female Labor Force(as % of total labor force) of Angola in 1995 to that in 1999?
Provide a succinct answer. 1.01. What is the ratio of the Female Labor Force(as % of total labor force) in Fiji in 1995 to that in 1999?
Offer a terse response. 0.95. What is the ratio of the Female Labor Force(as % of total labor force) in Guyana in 1995 to that in 1999?
Your response must be concise. 1. What is the ratio of the Female Labor Force(as % of total labor force) in Angola in 1995 to that in 2000?
Ensure brevity in your answer.  1.01. What is the ratio of the Female Labor Force(as % of total labor force) of Fiji in 1995 to that in 2000?
Offer a terse response. 0.95. What is the ratio of the Female Labor Force(as % of total labor force) in Guyana in 1995 to that in 2000?
Offer a terse response. 1. What is the ratio of the Female Labor Force(as % of total labor force) in Angola in 1995 to that in 2001?
Give a very brief answer. 1.02. What is the ratio of the Female Labor Force(as % of total labor force) of Fiji in 1995 to that in 2001?
Your answer should be very brief. 0.95. What is the ratio of the Female Labor Force(as % of total labor force) in Guyana in 1995 to that in 2001?
Give a very brief answer. 1. What is the ratio of the Female Labor Force(as % of total labor force) in Angola in 1996 to that in 1997?
Provide a succinct answer. 1. What is the ratio of the Female Labor Force(as % of total labor force) of Guyana in 1996 to that in 1997?
Offer a terse response. 1. What is the ratio of the Female Labor Force(as % of total labor force) in Angola in 1996 to that in 1998?
Offer a terse response. 1.01. What is the ratio of the Female Labor Force(as % of total labor force) of Fiji in 1996 to that in 1998?
Your answer should be compact. 1. What is the ratio of the Female Labor Force(as % of total labor force) in Angola in 1996 to that in 1999?
Offer a very short reply. 1.01. What is the ratio of the Female Labor Force(as % of total labor force) of Fiji in 1996 to that in 1999?
Your answer should be compact. 0.99. What is the ratio of the Female Labor Force(as % of total labor force) of Angola in 1996 to that in 2000?
Your response must be concise. 1.01. What is the ratio of the Female Labor Force(as % of total labor force) in Angola in 1996 to that in 2001?
Ensure brevity in your answer.  1.01. What is the ratio of the Female Labor Force(as % of total labor force) in Angola in 1997 to that in 1998?
Your response must be concise. 1. What is the ratio of the Female Labor Force(as % of total labor force) of Fiji in 1997 to that in 1998?
Give a very brief answer. 1. What is the ratio of the Female Labor Force(as % of total labor force) of Guyana in 1997 to that in 1998?
Keep it short and to the point. 1. What is the ratio of the Female Labor Force(as % of total labor force) of Fiji in 1997 to that in 1999?
Give a very brief answer. 1. What is the ratio of the Female Labor Force(as % of total labor force) in Guyana in 1997 to that in 1999?
Your answer should be very brief. 1. What is the ratio of the Female Labor Force(as % of total labor force) of Fiji in 1997 to that in 2000?
Give a very brief answer. 0.99. What is the ratio of the Female Labor Force(as % of total labor force) of Angola in 1997 to that in 2001?
Provide a short and direct response. 1.01. What is the ratio of the Female Labor Force(as % of total labor force) in Guyana in 1997 to that in 2001?
Provide a short and direct response. 1. What is the ratio of the Female Labor Force(as % of total labor force) in Angola in 1998 to that in 1999?
Ensure brevity in your answer.  1. What is the ratio of the Female Labor Force(as % of total labor force) in Fiji in 1998 to that in 1999?
Your answer should be very brief. 1. What is the ratio of the Female Labor Force(as % of total labor force) in Guyana in 1998 to that in 1999?
Your answer should be compact. 1. What is the ratio of the Female Labor Force(as % of total labor force) of Angola in 1998 to that in 2000?
Give a very brief answer. 1. What is the ratio of the Female Labor Force(as % of total labor force) of Guyana in 1998 to that in 2000?
Your answer should be very brief. 1. What is the ratio of the Female Labor Force(as % of total labor force) in Fiji in 1998 to that in 2001?
Your response must be concise. 0.99. What is the ratio of the Female Labor Force(as % of total labor force) in Guyana in 1998 to that in 2001?
Give a very brief answer. 1. What is the ratio of the Female Labor Force(as % of total labor force) in Guyana in 1999 to that in 2001?
Provide a short and direct response. 1. What is the ratio of the Female Labor Force(as % of total labor force) of Fiji in 2000 to that in 2001?
Give a very brief answer. 1. What is the ratio of the Female Labor Force(as % of total labor force) in Guyana in 2000 to that in 2001?
Provide a succinct answer. 1. What is the difference between the highest and the second highest Female Labor Force(as % of total labor force) in Angola?
Ensure brevity in your answer.  0.31. What is the difference between the highest and the second highest Female Labor Force(as % of total labor force) in Fiji?
Provide a short and direct response. 0.05. What is the difference between the highest and the second highest Female Labor Force(as % of total labor force) in Guyana?
Offer a terse response. 0.04. What is the difference between the highest and the lowest Female Labor Force(as % of total labor force) in Angola?
Offer a terse response. 1.06. What is the difference between the highest and the lowest Female Labor Force(as % of total labor force) in Fiji?
Your response must be concise. 2.94. What is the difference between the highest and the lowest Female Labor Force(as % of total labor force) of Guyana?
Keep it short and to the point. 0.19. 